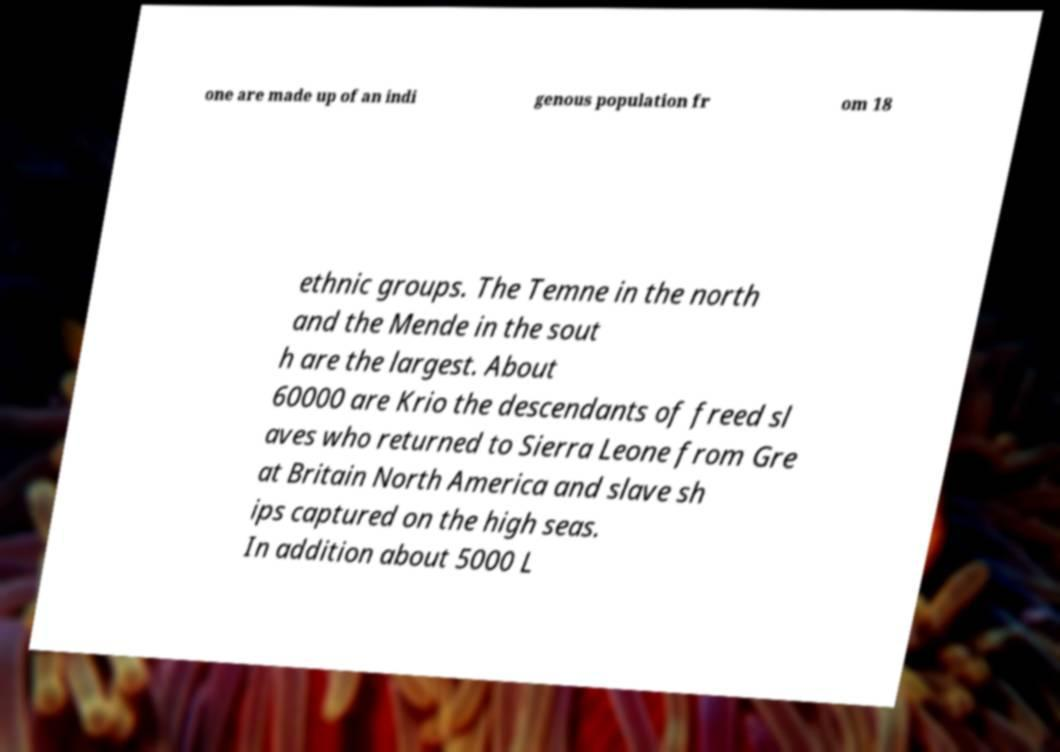Could you extract and type out the text from this image? one are made up of an indi genous population fr om 18 ethnic groups. The Temne in the north and the Mende in the sout h are the largest. About 60000 are Krio the descendants of freed sl aves who returned to Sierra Leone from Gre at Britain North America and slave sh ips captured on the high seas. In addition about 5000 L 